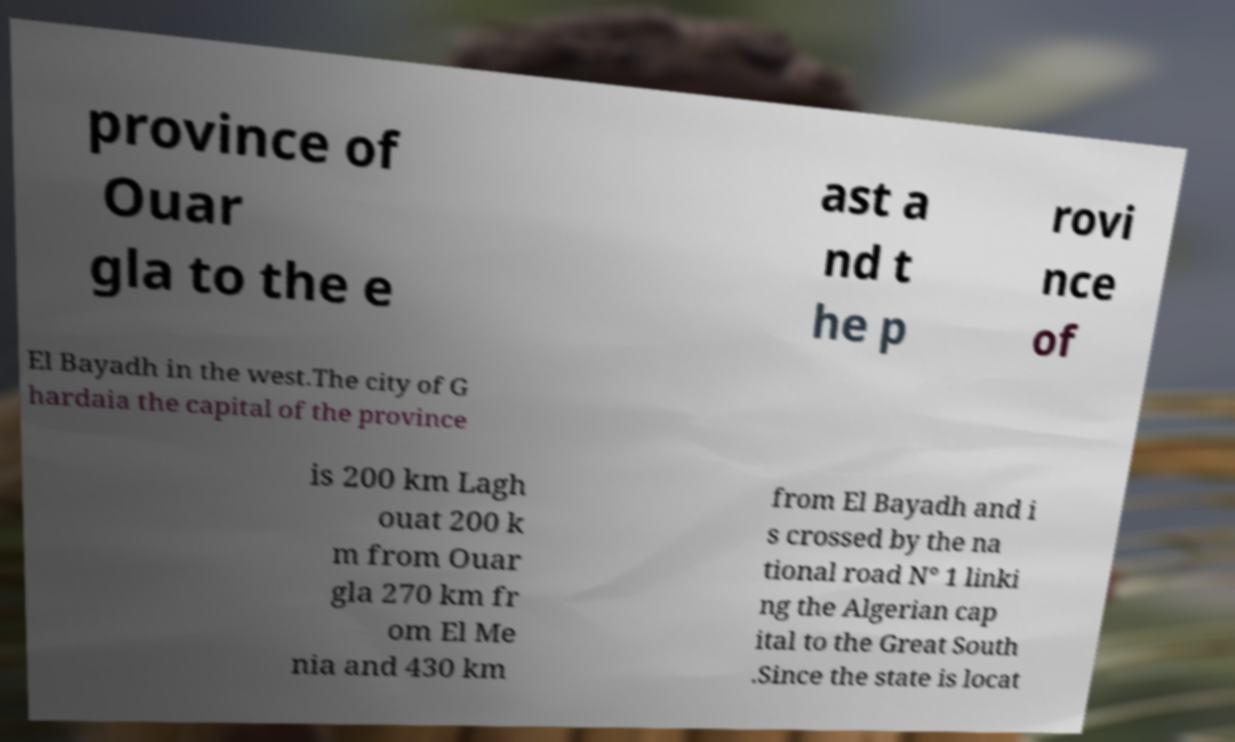Can you accurately transcribe the text from the provided image for me? province of Ouar gla to the e ast a nd t he p rovi nce of El Bayadh in the west.The city of G hardaia the capital of the province is 200 km Lagh ouat 200 k m from Ouar gla 270 km fr om El Me nia and 430 km from El Bayadh and i s crossed by the na tional road N° 1 linki ng the Algerian cap ital to the Great South .Since the state is locat 